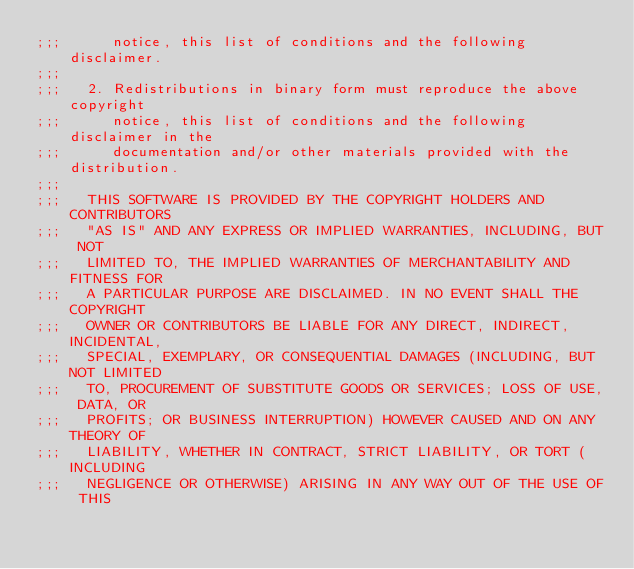Convert code to text. <code><loc_0><loc_0><loc_500><loc_500><_Scheme_>;;;      notice, this list of conditions and the following disclaimer.
;;;  
;;;   2. Redistributions in binary form must reproduce the above copyright
;;;      notice, this list of conditions and the following disclaimer in the
;;;      documentation and/or other materials provided with the distribution.
;;;  
;;;   THIS SOFTWARE IS PROVIDED BY THE COPYRIGHT HOLDERS AND CONTRIBUTORS
;;;   "AS IS" AND ANY EXPRESS OR IMPLIED WARRANTIES, INCLUDING, BUT NOT
;;;   LIMITED TO, THE IMPLIED WARRANTIES OF MERCHANTABILITY AND FITNESS FOR
;;;   A PARTICULAR PURPOSE ARE DISCLAIMED. IN NO EVENT SHALL THE COPYRIGHT
;;;   OWNER OR CONTRIBUTORS BE LIABLE FOR ANY DIRECT, INDIRECT, INCIDENTAL,
;;;   SPECIAL, EXEMPLARY, OR CONSEQUENTIAL DAMAGES (INCLUDING, BUT NOT LIMITED
;;;   TO, PROCUREMENT OF SUBSTITUTE GOODS OR SERVICES; LOSS OF USE, DATA, OR
;;;   PROFITS; OR BUSINESS INTERRUPTION) HOWEVER CAUSED AND ON ANY THEORY OF
;;;   LIABILITY, WHETHER IN CONTRACT, STRICT LIABILITY, OR TORT (INCLUDING
;;;   NEGLIGENCE OR OTHERWISE) ARISING IN ANY WAY OUT OF THE USE OF THIS</code> 